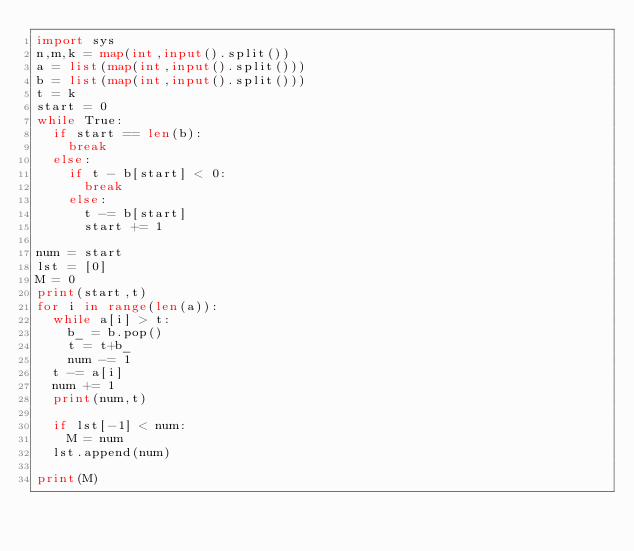Convert code to text. <code><loc_0><loc_0><loc_500><loc_500><_Python_>import sys
n,m,k = map(int,input().split())
a = list(map(int,input().split()))
b = list(map(int,input().split()))
t = k
start = 0
while True:
  if start == len(b):
    break
  else:
    if t - b[start] < 0:
      break
    else:  
      t -= b[start]
      start += 1

num = start
lst = [0]
M = 0
print(start,t)
for i in range(len(a)):
  while a[i] > t:
    b_ = b.pop()
    t = t+b_
    num -= 1
  t -= a[i]
  num += 1
  print(num,t)
 
  if lst[-1] < num:
    M = num
  lst.append(num)    
    
print(M)    
  </code> 